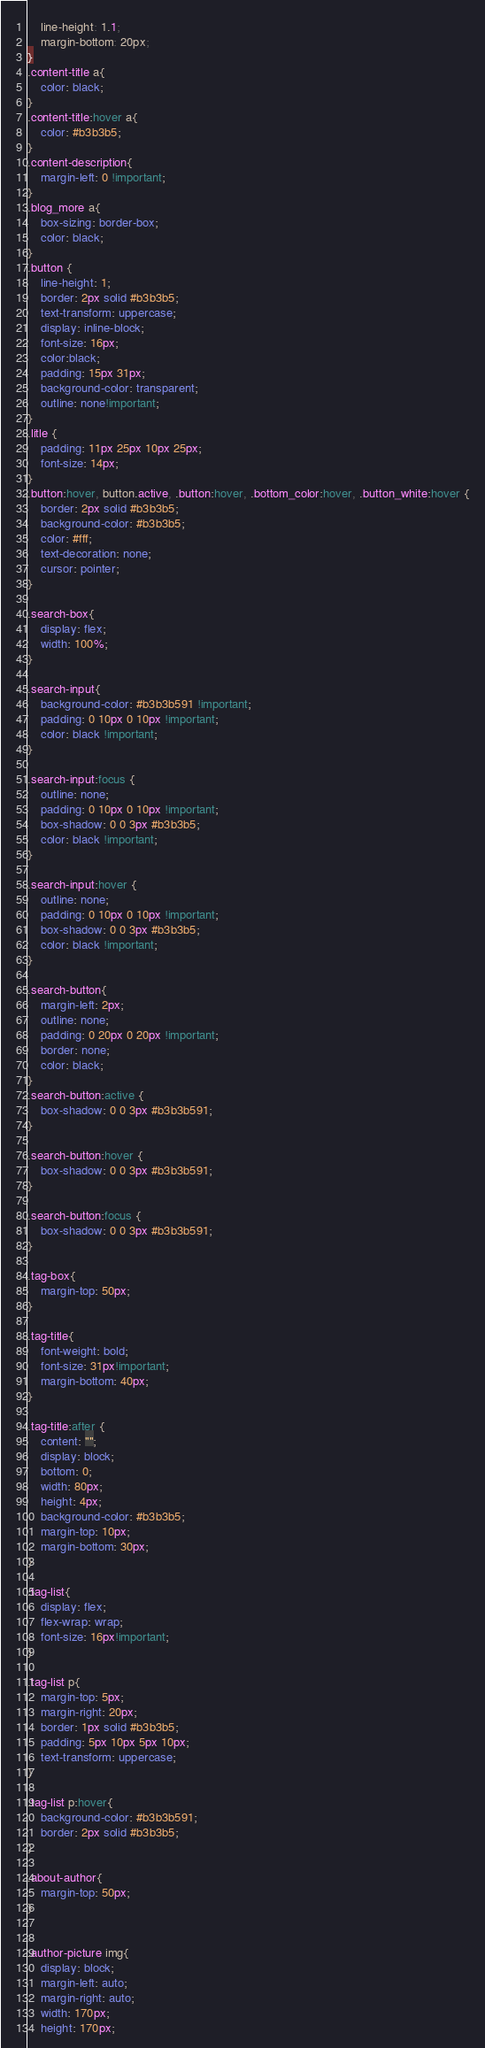Convert code to text. <code><loc_0><loc_0><loc_500><loc_500><_CSS_>    line-height: 1.1;
    margin-bottom: 20px;
}
.content-title a{
    color: black;
}
.content-title:hover a{
    color: #b3b3b5;
}
.content-description{
    margin-left: 0 !important;
}
.blog_more a{
    box-sizing: border-box;
    color: black;
}
.button {
    line-height: 1;
    border: 2px solid #b3b3b5;
    text-transform: uppercase;
    display: inline-block;
    font-size: 16px;
    color:black;
    padding: 15px 31px;
    background-color: transparent;
    outline: none!important;
}
.litle {
    padding: 11px 25px 10px 25px;
    font-size: 14px;
}
.button:hover, button.active, .button:hover, .bottom_color:hover, .button_white:hover {
    border: 2px solid #b3b3b5;
    background-color: #b3b3b5;
    color: #fff;
    text-decoration: none;
    cursor: pointer;
}

.search-box{
    display: flex;
    width: 100%;
}

.search-input{
    background-color: #b3b3b591 !important;
    padding: 0 10px 0 10px !important;
    color: black !important;
}

.search-input:focus {
    outline: none;
    padding: 0 10px 0 10px !important;
    box-shadow: 0 0 3px #b3b3b5;
    color: black !important;
}

.search-input:hover {
    outline: none;
    padding: 0 10px 0 10px !important;
    box-shadow: 0 0 3px #b3b3b5;
    color: black !important;
}

.search-button{
    margin-left: 2px;
    outline: none;
    padding: 0 20px 0 20px !important;
    border: none;
    color: black;
}
.search-button:active {
    box-shadow: 0 0 3px #b3b3b591;
}

.search-button:hover {
    box-shadow: 0 0 3px #b3b3b591;
}

.search-button:focus {
    box-shadow: 0 0 3px #b3b3b591;
}

.tag-box{
    margin-top: 50px;
}

.tag-title{
    font-weight: bold;
    font-size: 31px!important;
    margin-bottom: 40px;
}

.tag-title:after {
    content: "";
    display: block;
    bottom: 0;
    width: 80px;
    height: 4px;
    background-color: #b3b3b5;
    margin-top: 10px;
    margin-bottom: 30px;
}

.tag-list{
    display: flex;
    flex-wrap: wrap;
    font-size: 16px!important;
}

.tag-list p{
    margin-top: 5px;
    margin-right: 20px;
    border: 1px solid #b3b3b5;
    padding: 5px 10px 5px 10px;
    text-transform: uppercase;
}

.tag-list p:hover{
    background-color: #b3b3b591;
    border: 2px solid #b3b3b5;
}

.about-author{
    margin-top: 50px;
}


.author-picture img{
    display: block;
    margin-left: auto;
    margin-right: auto;
    width: 170px;
    height: 170px;</code> 